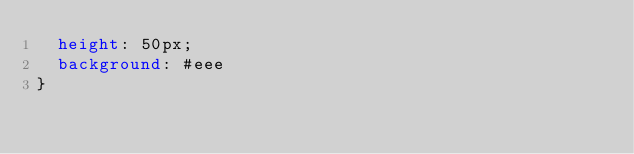Convert code to text. <code><loc_0><loc_0><loc_500><loc_500><_CSS_>  height: 50px;
  background: #eee
}</code> 